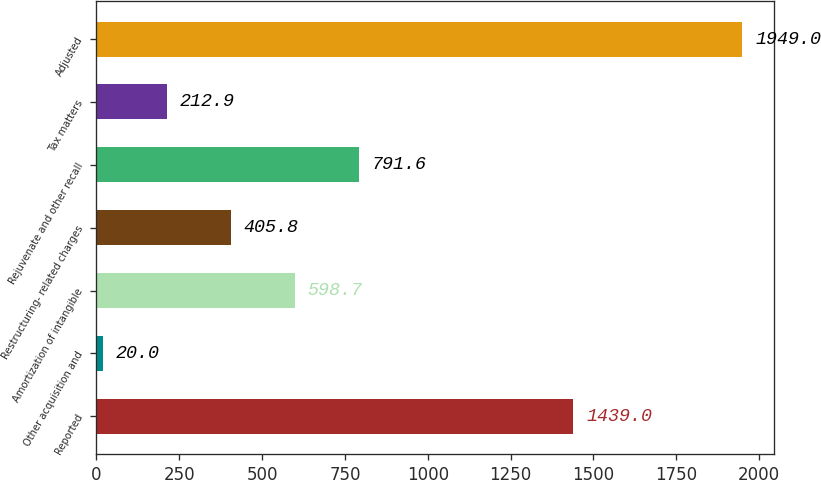Convert chart to OTSL. <chart><loc_0><loc_0><loc_500><loc_500><bar_chart><fcel>Reported<fcel>Other acquisition and<fcel>Amortization of intangible<fcel>Restructuring- related charges<fcel>Rejuvenate and other recall<fcel>Tax matters<fcel>Adjusted<nl><fcel>1439<fcel>20<fcel>598.7<fcel>405.8<fcel>791.6<fcel>212.9<fcel>1949<nl></chart> 